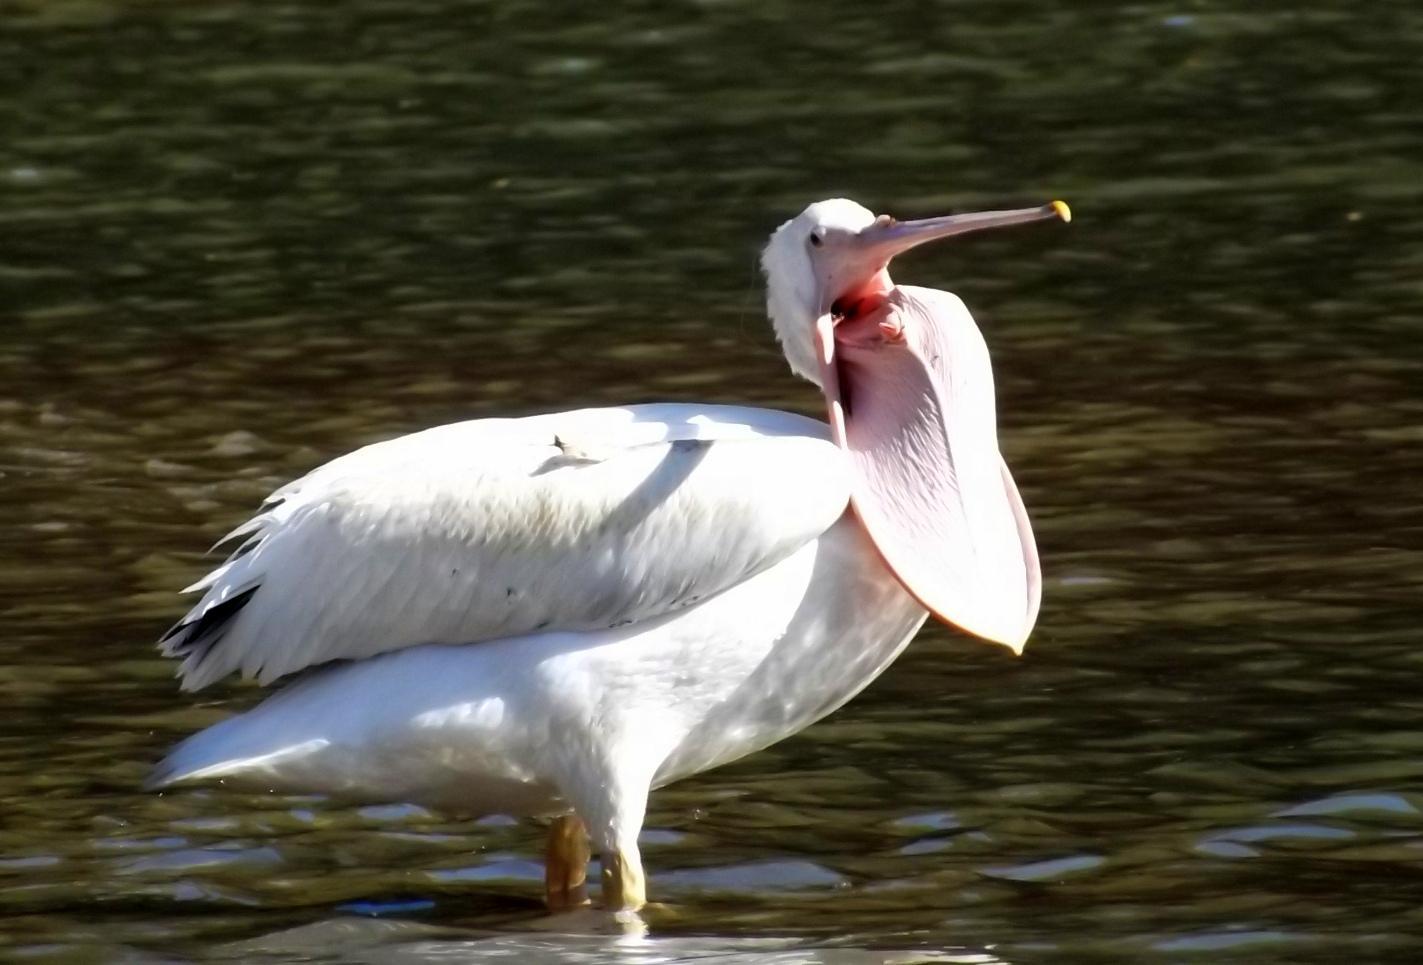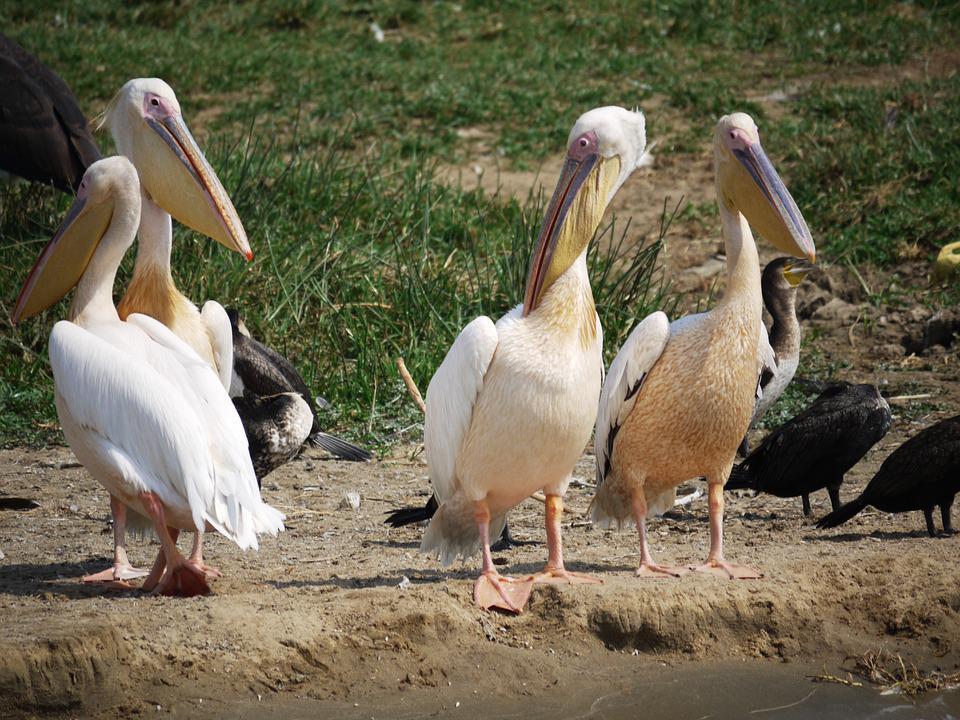The first image is the image on the left, the second image is the image on the right. Examine the images to the left and right. Is the description "Right image shows pelicans with smaller dark birds." accurate? Answer yes or no. Yes. 